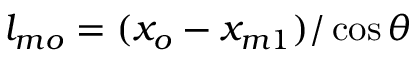Convert formula to latex. <formula><loc_0><loc_0><loc_500><loc_500>l _ { m o } = ( x _ { o } - x _ { m 1 } ) / \cos { \theta }</formula> 